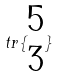Convert formula to latex. <formula><loc_0><loc_0><loc_500><loc_500>t r \{ \begin{matrix} 5 \\ 3 \end{matrix} \}</formula> 